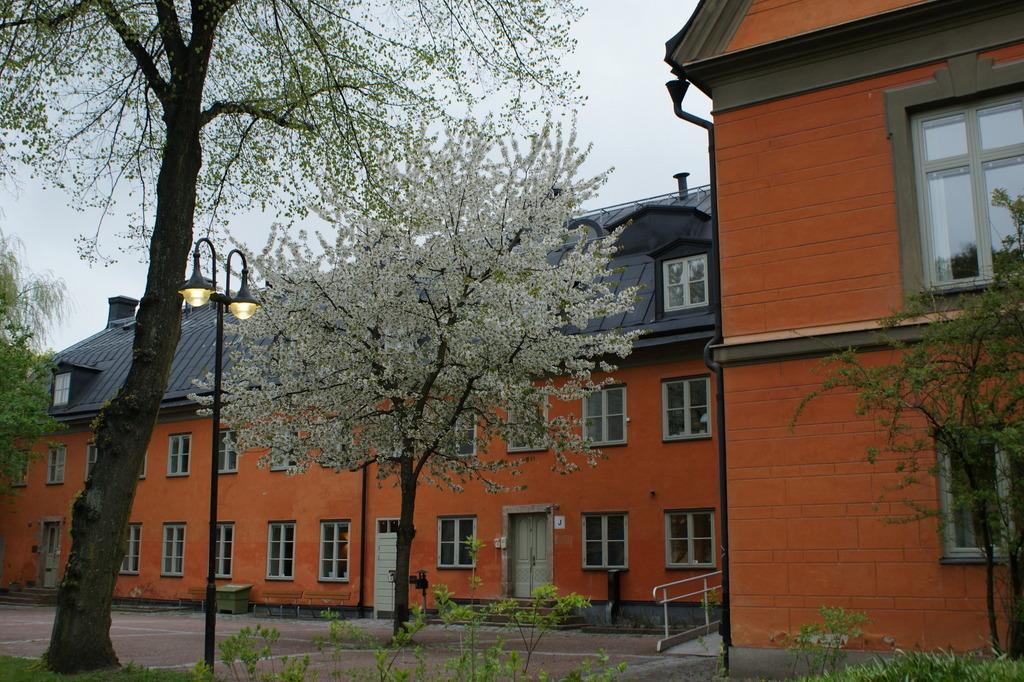What can be seen in the background of the image? The sky is visible in the background of the image. What type of structures are present in the image? There are buildings in the image. What architectural features can be observed in the image? Windows, poles, and railing are present in the image. What natural elements are visible in the image? Trees and plants are present in the image. What additional objects can be seen in the image? Lights and other objects are visible in the image. What type of cake is being served at the theory conference in the image? There is no cake or theory conference present in the image. Can you tell me how many cans are visible in the image? There are no cans visible in the image. 